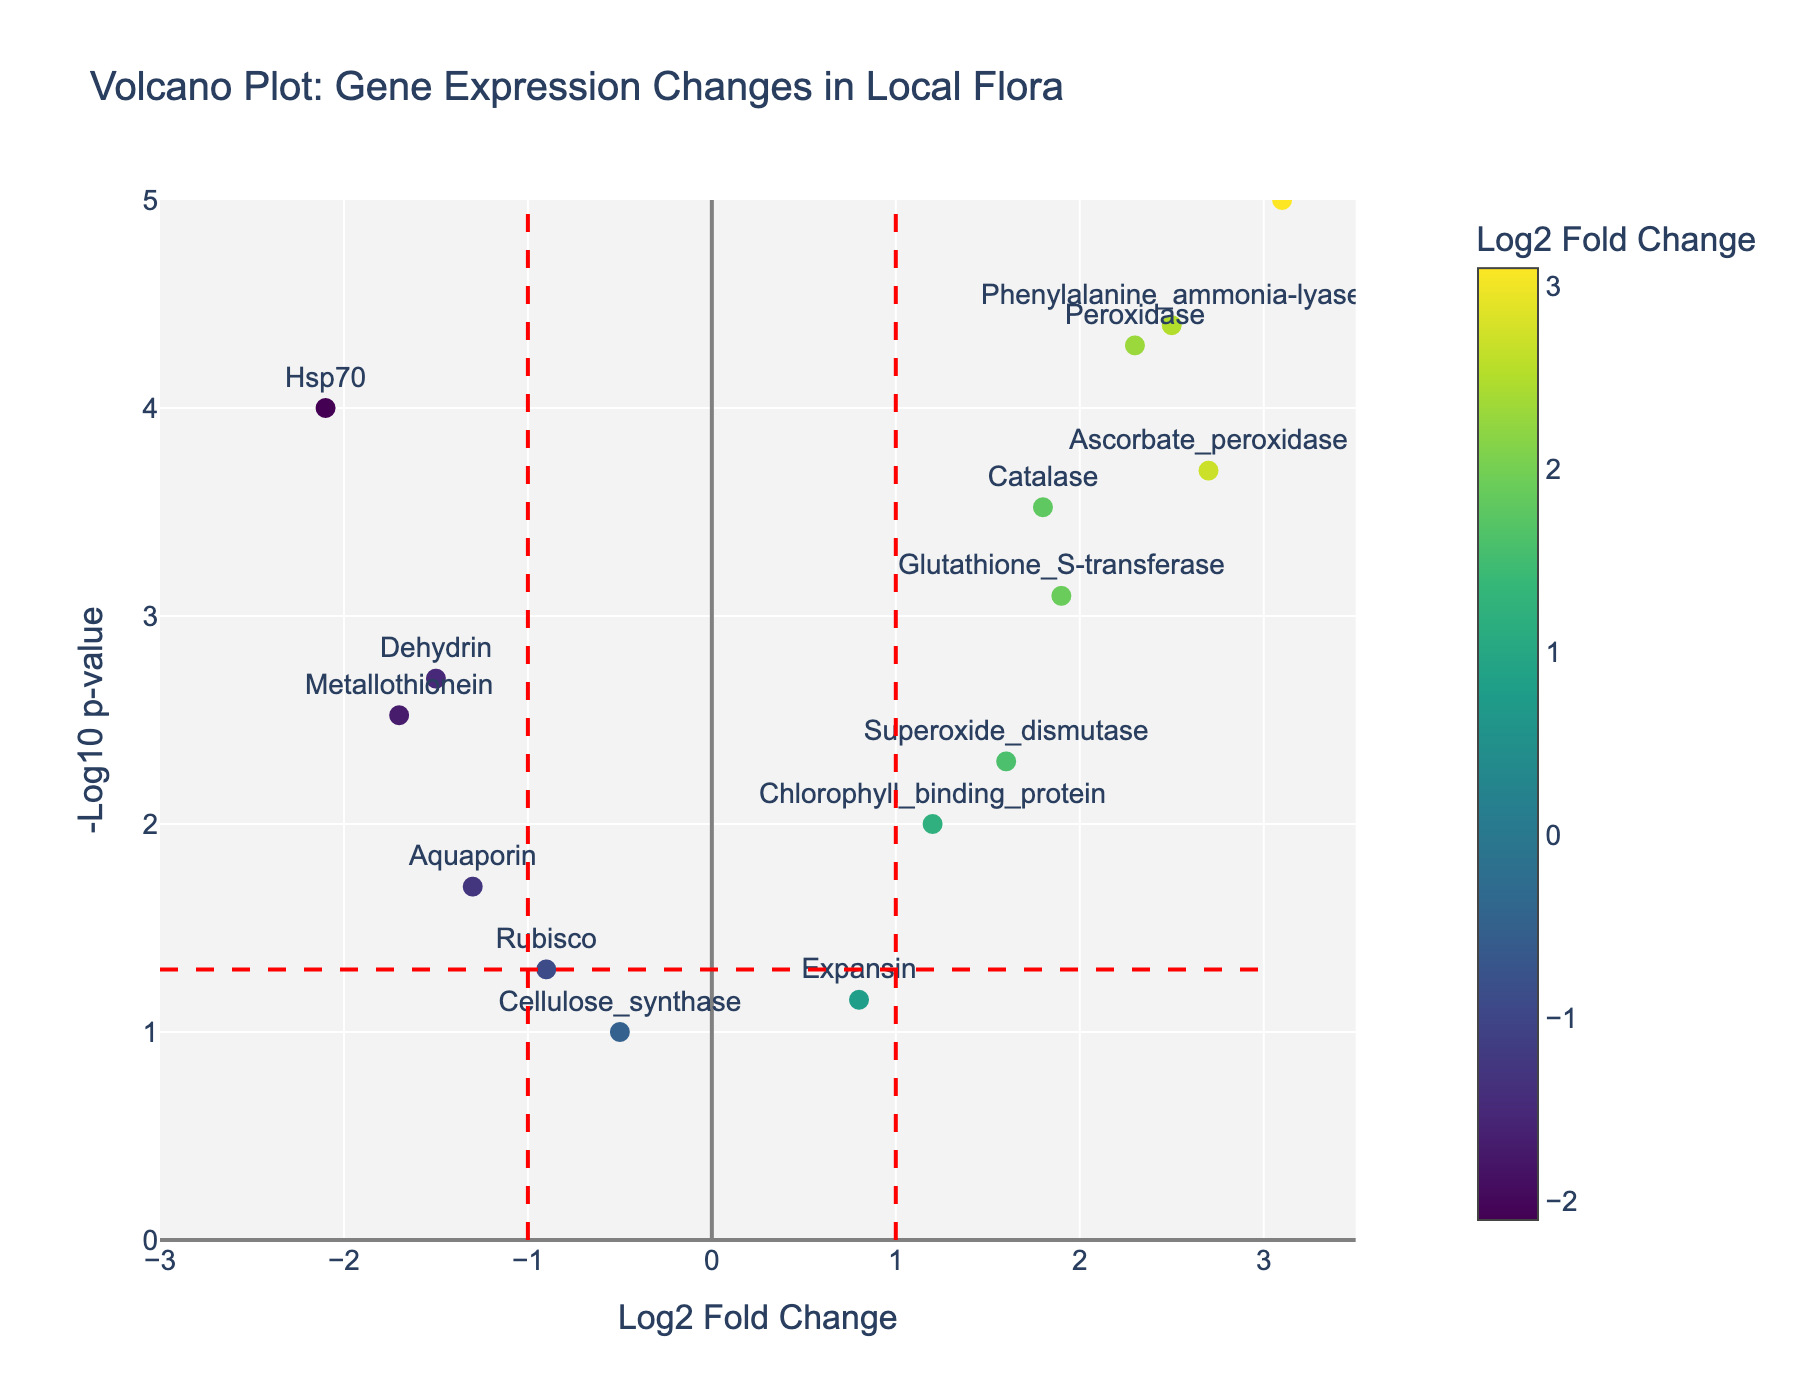How many genes have a positive log2 fold change? To find the number of genes with positive log2 fold change, count the points on the right side of the y-axis (x > 0).
Answer: 8 What is the log2 fold change of the gene 'LEA_protein'? Identify the gene 'LEA_protein' and find its corresponding log2 fold change on the x-axis.
Answer: 3.1 Which gene has the lowest p-value? The gene with the lowest p-value will have the highest -log10(p-value) value on the y-axis. By inspecting the vertical positions of the points, find the highest point.
Answer: LEA_protein How many genes are considered statistically significant with a p-value less than 0.05? Locate the red horizontal line at -log10(0.05) on the plot. Count all data points above this line.
Answer: 10 Which genes fall within the threshold of log2 fold change between -1 and 1? Identify the region between x = -1 and x = 1 and count all gene names in this interval.
Answer: Rubisco, Aquaporin, Expansin, Cellulose_synthase What gene appears at log2 fold change = 2.5 and what can you say about its p-value? Locate log2 fold change of 2.5 on the x-axis and identify the corresponding gene. Check its vertical position for p-value inference.
Answer: Phenylalanine_ammonia-lyase; p-value is very low If we consider genes with an absolute log2 fold change greater than 2 and a p-value less than 0.001 as highly significant, how many genes meet this criterion? Identify genes with absolute log2 fold change > 2 (x < -2 or x > 2) and p-value threshold -log10(p-value) > -log10(0.001). Count these genes.
Answer: 3 What is the color variation representing in the plot? Look at the color legend next to the plot, which shows that the colors indicate the magnitude of the log2 fold change.
Answer: Log2 Fold Change Which gene has the second highest -log10(p-value)? After identifying the gene with the highest -log10(p-value), find the next gene in vertical position.
Answer: Phenylalanine_ammonia-lyase Compare the expression changes of 'Glutathione_S-transferase' and 'Metallothionein'. Which one shows a larger fold change? Check the log2 fold change values on the x-axis for both genes. Compare their magnitudes irrespective of sign.
Answer: Glutathione_S-transferase 